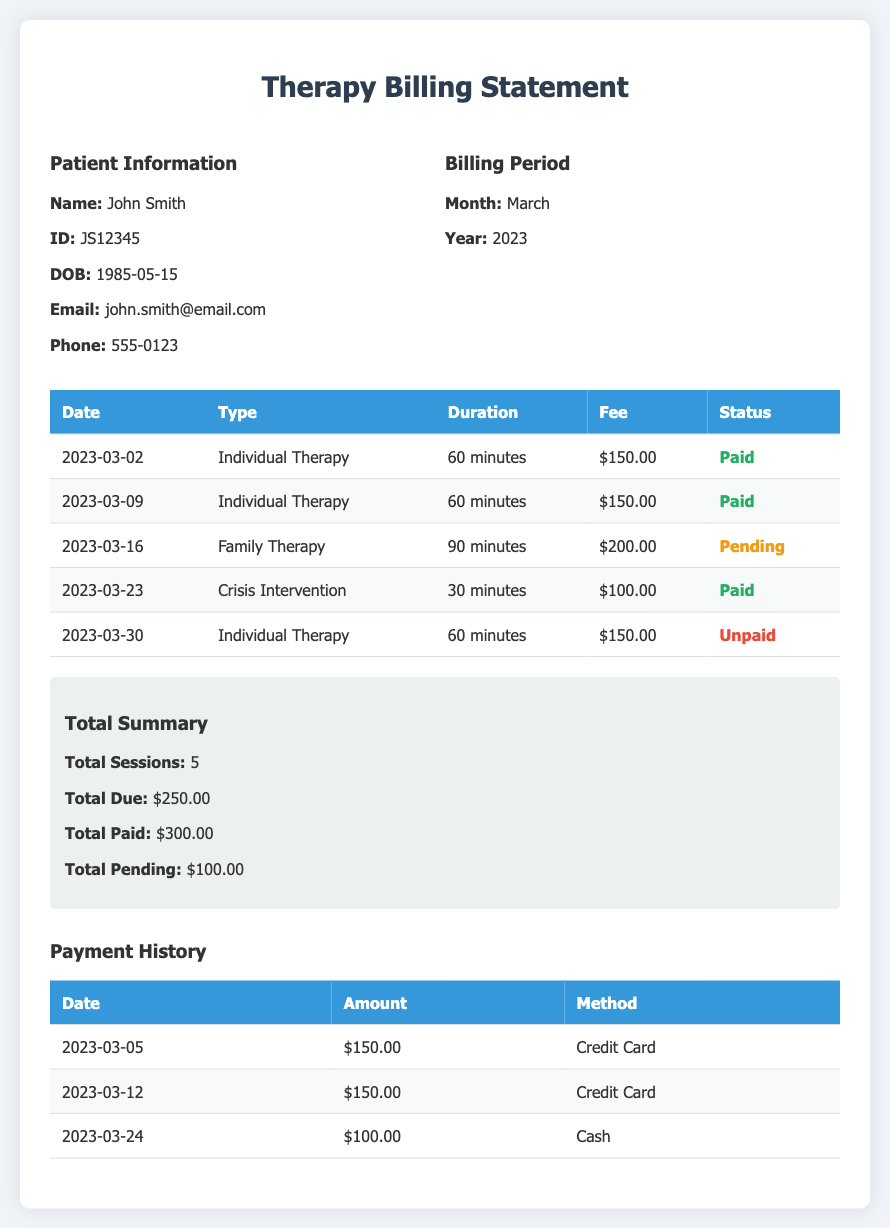What is the patient's name? The document specifies the patient's name as John Smith.
Answer: John Smith How many total sessions were attended? The total number of therapy sessions attended is provided in the summary as 5.
Answer: 5 What was the fee for family therapy? The fee for family therapy is listed in the session details as $200.00.
Answer: $200.00 What is the date of the unpaid session? The document shows that the unpaid session occurred on March 30, 2023.
Answer: 2023-03-30 What is the total due amount? The total due amount is indicated in the summary as $250.00.
Answer: $250.00 How many sessions are marked as paid? By evaluating the session statuses, there are 3 sessions marked as paid.
Answer: 3 What payment method was used on March 24, 2023? The payment history shows that the payment on this date was made via cash.
Answer: Cash What is the duration of the crisis intervention session? The document notes that the crisis intervention session lasted for 30 minutes.
Answer: 30 minutes What is the total paid amount? The summary states that the total paid amount is $300.00.
Answer: $300.00 